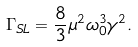Convert formula to latex. <formula><loc_0><loc_0><loc_500><loc_500>\Gamma _ { S L } = \frac { 8 } { 3 } \mu ^ { 2 } \omega _ { 0 } ^ { 3 } \gamma ^ { 2 } .</formula> 